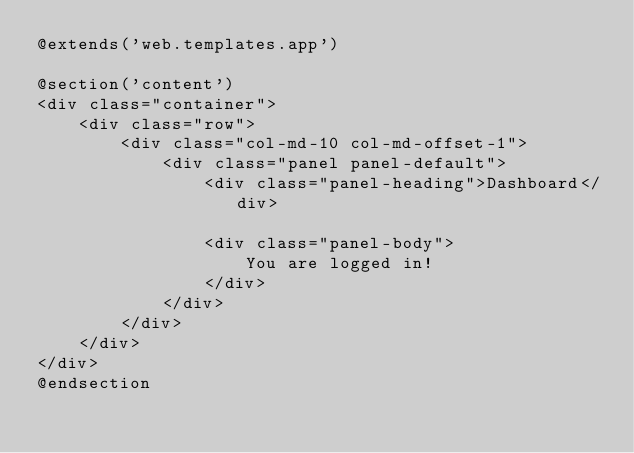<code> <loc_0><loc_0><loc_500><loc_500><_PHP_>@extends('web.templates.app')

@section('content')
<div class="container">
    <div class="row">
        <div class="col-md-10 col-md-offset-1">
            <div class="panel panel-default">
                <div class="panel-heading">Dashboard</div>

                <div class="panel-body">
                    You are logged in!
                </div>
            </div>
        </div>
    </div>
</div>
@endsection
</code> 